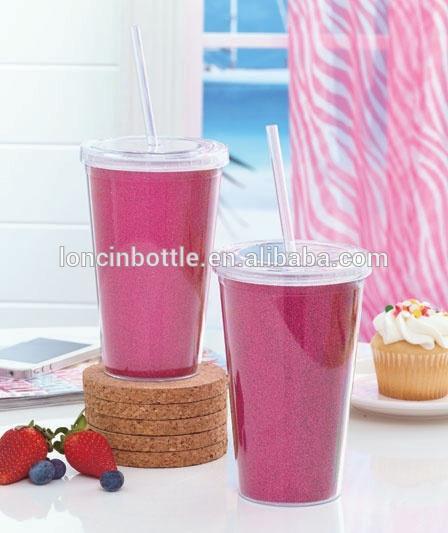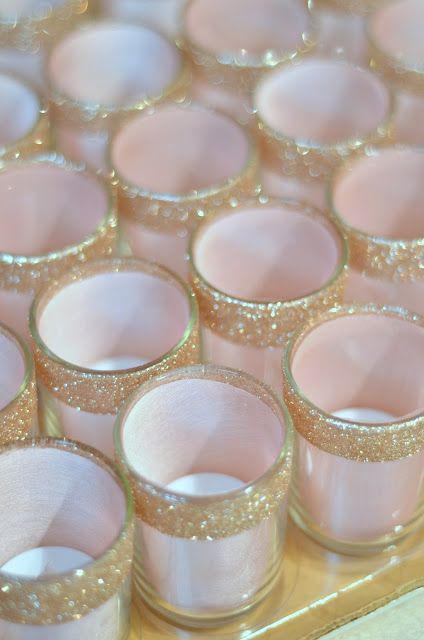The first image is the image on the left, the second image is the image on the right. Evaluate the accuracy of this statement regarding the images: "Both images have pink lemonade in glass dishes.". Is it true? Answer yes or no. No. The first image is the image on the left, the second image is the image on the right. Examine the images to the left and right. Is the description "There are straws in the right image." accurate? Answer yes or no. No. 